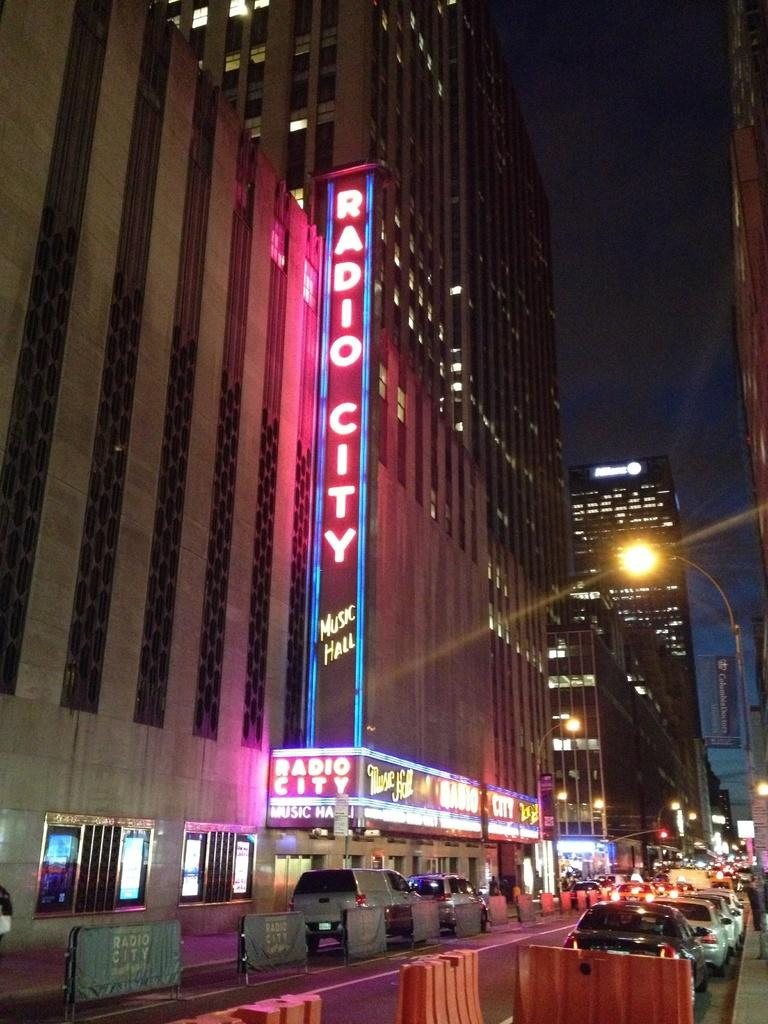What can be seen on the road in the image? There are barricades and vehicles on the road in the image. What else is present on the road besides the vehicles? There are street lights on the road in the image. What can be seen in the background of the image? There are buildings and lights visible in the background of the image. What type of wool is being used to knit the blade in the image? There is no wool or blade present in the image; it features barricades, vehicles, street lights, buildings, and lights. How many toes can be seen on the person walking in the image? There is no person walking in the image, so it is not possible to determine the number of toes visible. 